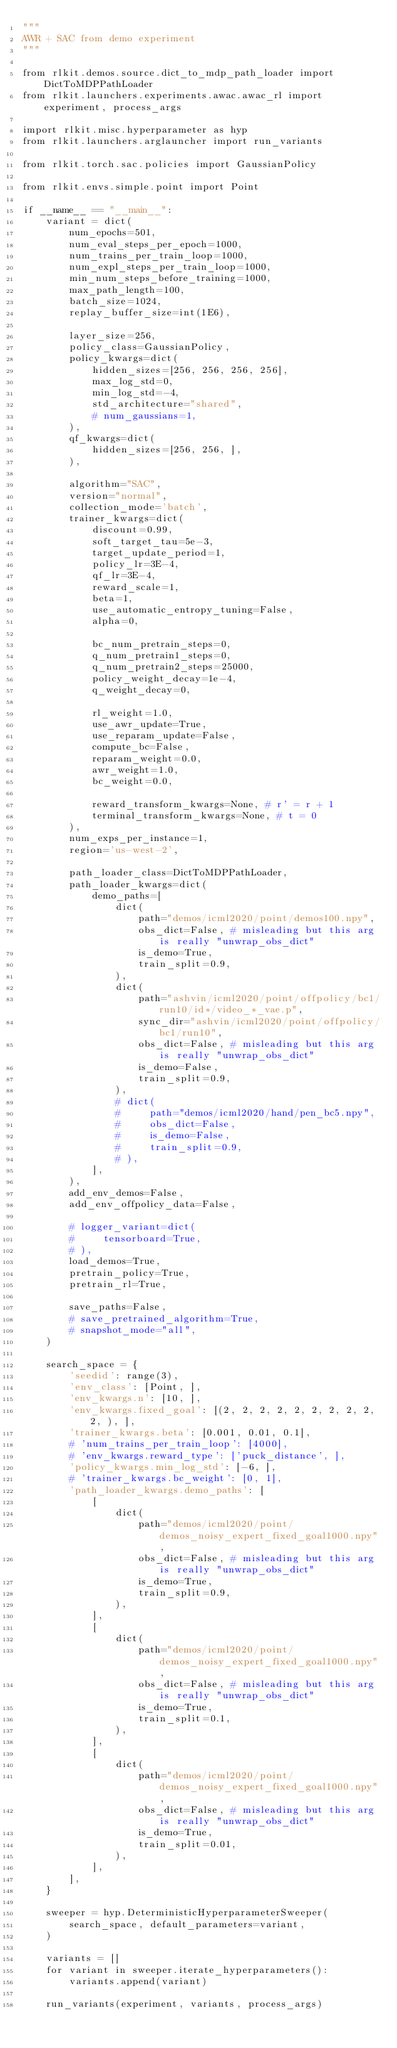Convert code to text. <code><loc_0><loc_0><loc_500><loc_500><_Python_>"""
AWR + SAC from demo experiment
"""

from rlkit.demos.source.dict_to_mdp_path_loader import DictToMDPPathLoader
from rlkit.launchers.experiments.awac.awac_rl import experiment, process_args

import rlkit.misc.hyperparameter as hyp
from rlkit.launchers.arglauncher import run_variants

from rlkit.torch.sac.policies import GaussianPolicy

from rlkit.envs.simple.point import Point

if __name__ == "__main__":
    variant = dict(
        num_epochs=501,
        num_eval_steps_per_epoch=1000,
        num_trains_per_train_loop=1000,
        num_expl_steps_per_train_loop=1000,
        min_num_steps_before_training=1000,
        max_path_length=100,
        batch_size=1024,
        replay_buffer_size=int(1E6),

        layer_size=256,
        policy_class=GaussianPolicy,
        policy_kwargs=dict(
            hidden_sizes=[256, 256, 256, 256],
            max_log_std=0,
            min_log_std=-4,
            std_architecture="shared",
            # num_gaussians=1,
        ),
        qf_kwargs=dict(
            hidden_sizes=[256, 256, ],
        ),

        algorithm="SAC",
        version="normal",
        collection_mode='batch',
        trainer_kwargs=dict(
            discount=0.99,
            soft_target_tau=5e-3,
            target_update_period=1,
            policy_lr=3E-4,
            qf_lr=3E-4,
            reward_scale=1,
            beta=1,
            use_automatic_entropy_tuning=False,
            alpha=0,

            bc_num_pretrain_steps=0,
            q_num_pretrain1_steps=0,
            q_num_pretrain2_steps=25000,
            policy_weight_decay=1e-4,
            q_weight_decay=0,

            rl_weight=1.0,
            use_awr_update=True,
            use_reparam_update=False,
            compute_bc=False,
            reparam_weight=0.0,
            awr_weight=1.0,
            bc_weight=0.0,

            reward_transform_kwargs=None, # r' = r + 1
            terminal_transform_kwargs=None, # t = 0
        ),
        num_exps_per_instance=1,
        region='us-west-2',

        path_loader_class=DictToMDPPathLoader,
        path_loader_kwargs=dict(
            demo_paths=[
                dict(
                    path="demos/icml2020/point/demos100.npy",
                    obs_dict=False, # misleading but this arg is really "unwrap_obs_dict"
                    is_demo=True,
                    train_split=0.9,
                ),
                dict(
                    path="ashvin/icml2020/point/offpolicy/bc1/run10/id*/video_*_vae.p",
                    sync_dir="ashvin/icml2020/point/offpolicy/bc1/run10",
                    obs_dict=False, # misleading but this arg is really "unwrap_obs_dict"
                    is_demo=False,
                    train_split=0.9,
                ),
                # dict(
                #     path="demos/icml2020/hand/pen_bc5.npy",
                #     obs_dict=False,
                #     is_demo=False,
                #     train_split=0.9,
                # ),
            ],
        ),
        add_env_demos=False,
        add_env_offpolicy_data=False,

        # logger_variant=dict(
        #     tensorboard=True,
        # ),
        load_demos=True,
        pretrain_policy=True,
        pretrain_rl=True,

        save_paths=False,
        # save_pretrained_algorithm=True,
        # snapshot_mode="all",
    )

    search_space = {
        'seedid': range(3),
        'env_class': [Point, ],
        'env_kwargs.n': [10, ],
        'env_kwargs.fixed_goal': [(2, 2, 2, 2, 2, 2, 2, 2, 2, 2, ), ],
        'trainer_kwargs.beta': [0.001, 0.01, 0.1],
        # 'num_trains_per_train_loop': [4000],
        # 'env_kwargs.reward_type': ['puck_distance', ],
        'policy_kwargs.min_log_std': [-6, ],
        # 'trainer_kwargs.bc_weight': [0, 1],
        'path_loader_kwargs.demo_paths': [
            [
                dict(
                    path="demos/icml2020/point/demos_noisy_expert_fixed_goal1000.npy",
                    obs_dict=False, # misleading but this arg is really "unwrap_obs_dict"
                    is_demo=True,
                    train_split=0.9,
                ),
            ],
            [
                dict(
                    path="demos/icml2020/point/demos_noisy_expert_fixed_goal1000.npy",
                    obs_dict=False, # misleading but this arg is really "unwrap_obs_dict"
                    is_demo=True,
                    train_split=0.1,
                ),
            ],
            [
                dict(
                    path="demos/icml2020/point/demos_noisy_expert_fixed_goal1000.npy",
                    obs_dict=False, # misleading but this arg is really "unwrap_obs_dict"
                    is_demo=True,
                    train_split=0.01,
                ),
            ],
        ],
    }

    sweeper = hyp.DeterministicHyperparameterSweeper(
        search_space, default_parameters=variant,
    )

    variants = []
    for variant in sweeper.iterate_hyperparameters():
        variants.append(variant)

    run_variants(experiment, variants, process_args)
</code> 